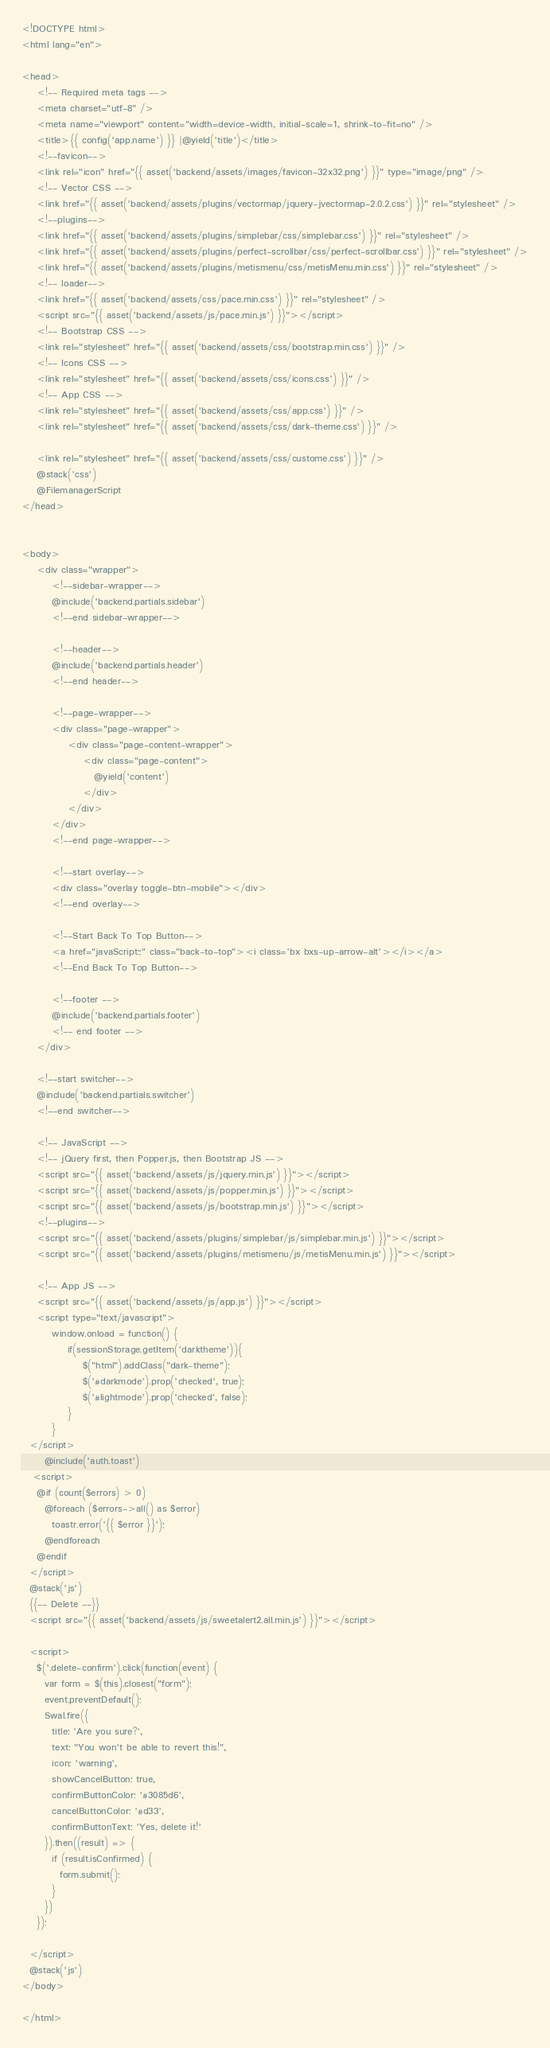<code> <loc_0><loc_0><loc_500><loc_500><_PHP_><!DOCTYPE html>
<html lang="en">

<head>
    <!-- Required meta tags -->
    <meta charset="utf-8" />
    <meta name="viewport" content="width=device-width, initial-scale=1, shrink-to-fit=no" />
    <title>{{ config('app.name') }} |@yield('title')</title>
    <!--favicon-->
    <link rel="icon" href="{{ asset('backend/assets/images/favicon-32x32.png') }}" type="image/png" />
    <!-- Vector CSS -->
    <link href="{{ asset('backend/assets/plugins/vectormap/jquery-jvectormap-2.0.2.css') }}" rel="stylesheet" />
    <!--plugins-->
    <link href="{{ asset('backend/assets/plugins/simplebar/css/simplebar.css') }}" rel="stylesheet" />
    <link href="{{ asset('backend/assets/plugins/perfect-scrollbar/css/perfect-scrollbar.css') }}" rel="stylesheet" />
    <link href="{{ asset('backend/assets/plugins/metismenu/css/metisMenu.min.css') }}" rel="stylesheet" />
    <!-- loader-->
    <link href="{{ asset('backend/assets/css/pace.min.css') }}" rel="stylesheet" />
    <script src="{{ asset('backend/assets/js/pace.min.js') }}"></script>
    <!-- Bootstrap CSS -->
    <link rel="stylesheet" href="{{ asset('backend/assets/css/bootstrap.min.css') }}" />
    <!-- Icons CSS -->
    <link rel="stylesheet" href="{{ asset('backend/assets/css/icons.css') }}" />
    <!-- App CSS -->
    <link rel="stylesheet" href="{{ asset('backend/assets/css/app.css') }}" />
    <link rel="stylesheet" href="{{ asset('backend/assets/css/dark-theme.css') }}" />

    <link rel="stylesheet" href="{{ asset('backend/assets/css/custome.css') }}" />
    @stack('css')
    @FilemanagerScript
</head>


<body>
    <div class="wrapper">
        <!--sidebar-wrapper-->
        @include('backend.partials.sidebar')
        <!--end sidebar-wrapper-->

        <!--header-->
        @include('backend.partials.header')
        <!--end header-->

        <!--page-wrapper-->
        <div class="page-wrapper">
            <div class="page-content-wrapper">
                <div class="page-content">
                   @yield('content')
                </div>
            </div>
        </div>
        <!--end page-wrapper-->

        <!--start overlay-->
        <div class="overlay toggle-btn-mobile"></div>
        <!--end overlay-->

        <!--Start Back To Top Button-->
        <a href="javaScript:;" class="back-to-top"><i class='bx bxs-up-arrow-alt'></i></a>
        <!--End Back To Top Button-->

        <!--footer -->
        @include('backend.partials.footer')
        <!-- end footer -->
    </div>

    <!--start switcher-->
    @include('backend.partials.switcher')
    <!--end switcher-->

    <!-- JavaScript -->
    <!-- jQuery first, then Popper.js, then Bootstrap JS -->
    <script src="{{ asset('backend/assets/js/jquery.min.js') }}"></script>
    <script src="{{ asset('backend/assets/js/popper.min.js') }}"></script>
    <script src="{{ asset('backend/assets/js/bootstrap.min.js') }}"></script>
    <!--plugins-->
    <script src="{{ asset('backend/assets/plugins/simplebar/js/simplebar.min.js') }}"></script>
    <script src="{{ asset('backend/assets/plugins/metismenu/js/metisMenu.min.js') }}"></script>

    <!-- App JS -->
    <script src="{{ asset('backend/assets/js/app.js') }}"></script>
    <script type="text/javascript">
        window.onload = function() {
            if(sessionStorage.getItem('darktheme')){
                $("html").addClass("dark-theme");
                $('#darkmode').prop('checked', true);
                $('#lightmode').prop('checked', false);
            }
        }
  </script>
      @include('auth.toast')
   <script>
    @if (count($errors) > 0)
      @foreach ($errors->all() as $error)
        toastr.error('{{ $error }}');
      @endforeach
    @endif
  </script>
  @stack('js')
  {{-- Delete --}}
  <script src="{{ asset('backend/assets/js/sweetalert2.all.min.js') }}"></script>

  <script>
    $('.delete-confirm').click(function(event) {
      var form = $(this).closest("form");
      event.preventDefault();
      Swal.fire({
        title: 'Are you sure?',
        text: "You won't be able to revert this!",
        icon: 'warning',
        showCancelButton: true,
        confirmButtonColor: '#3085d6',
        cancelButtonColor: '#d33',
        confirmButtonText: 'Yes, delete it!'
      }).then((result) => {
        if (result.isConfirmed) {
          form.submit();
        }
      })
    });

  </script>
  @stack('js')
</body>

</html>
</code> 